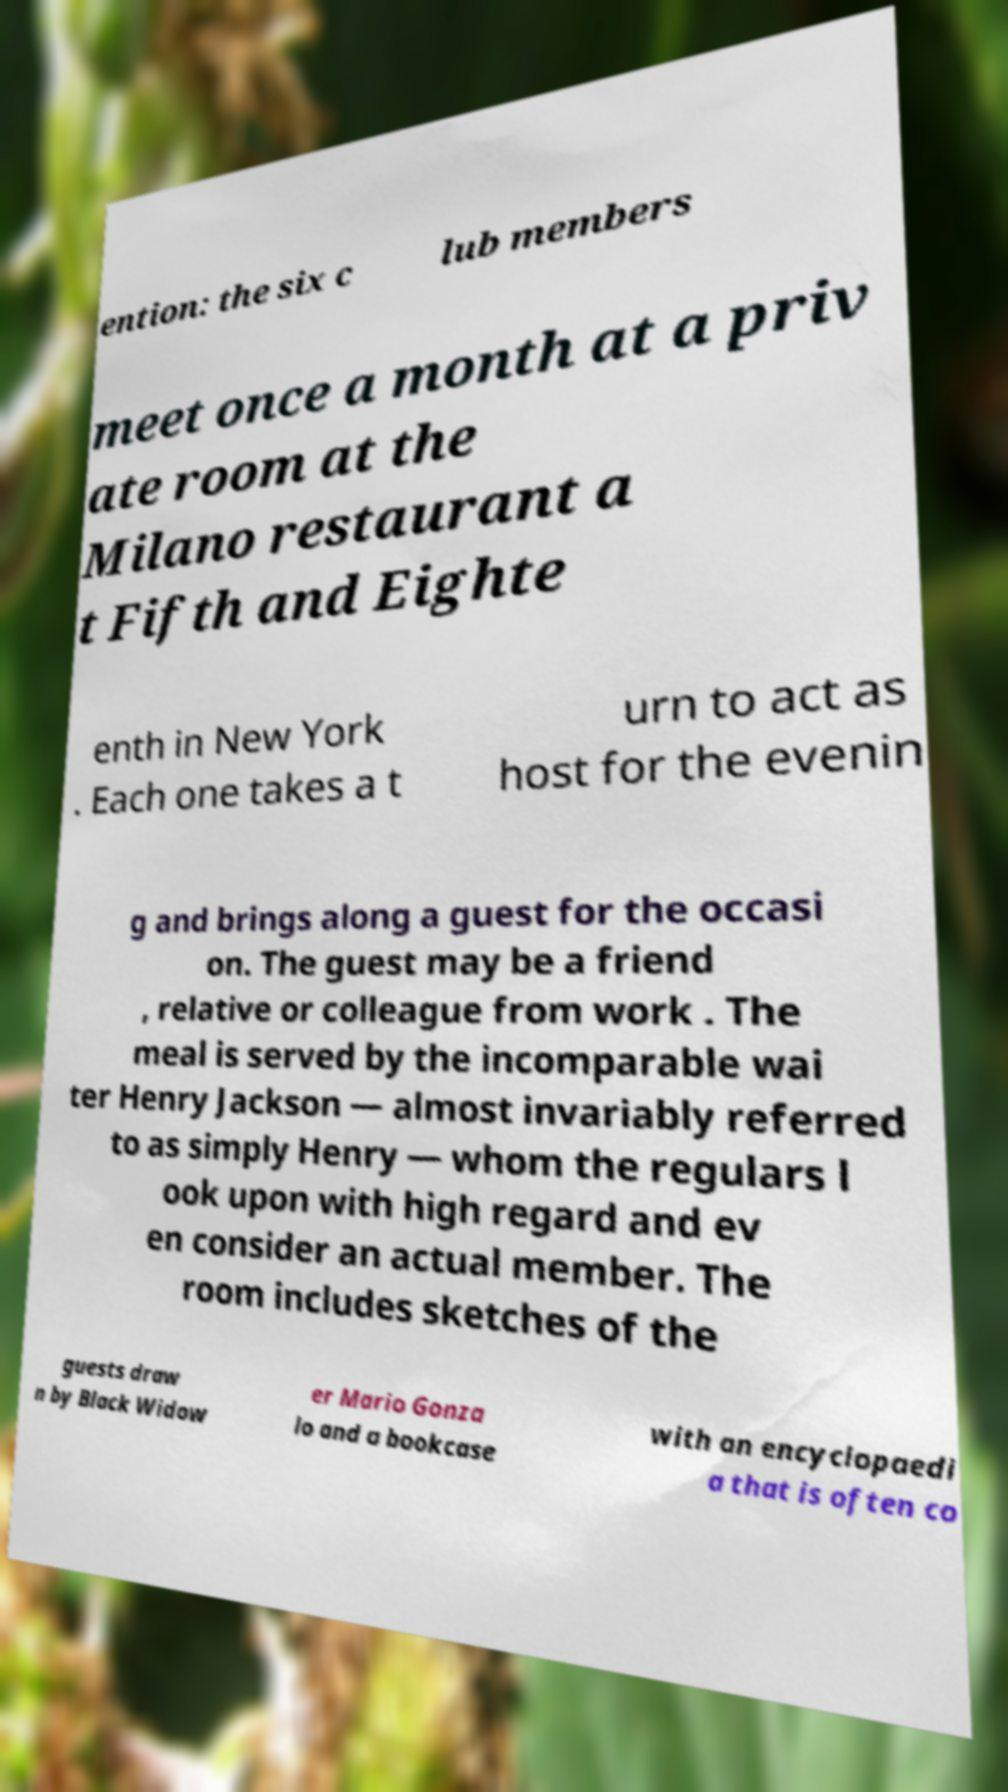I need the written content from this picture converted into text. Can you do that? ention: the six c lub members meet once a month at a priv ate room at the Milano restaurant a t Fifth and Eighte enth in New York . Each one takes a t urn to act as host for the evenin g and brings along a guest for the occasi on. The guest may be a friend , relative or colleague from work . The meal is served by the incomparable wai ter Henry Jackson — almost invariably referred to as simply Henry — whom the regulars l ook upon with high regard and ev en consider an actual member. The room includes sketches of the guests draw n by Black Widow er Mario Gonza lo and a bookcase with an encyclopaedi a that is often co 